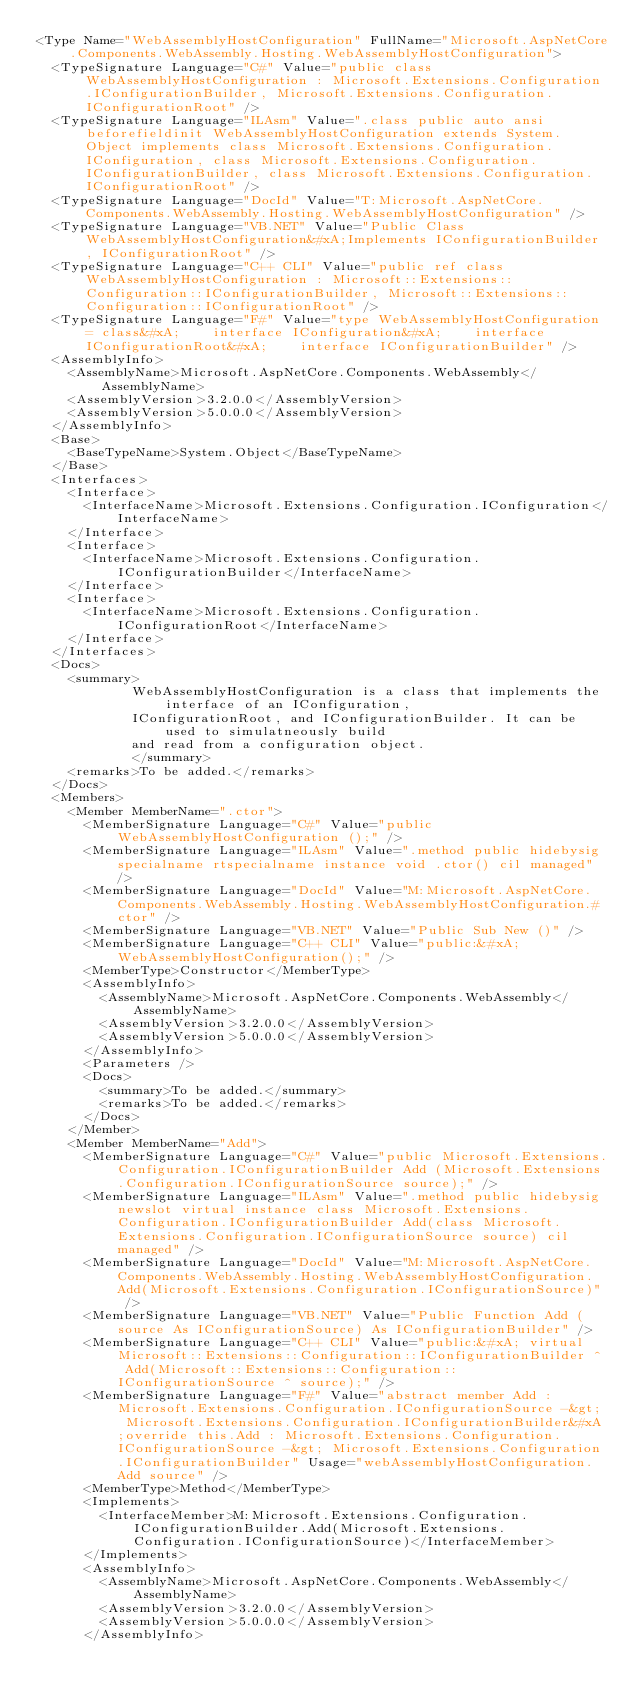Convert code to text. <code><loc_0><loc_0><loc_500><loc_500><_XML_><Type Name="WebAssemblyHostConfiguration" FullName="Microsoft.AspNetCore.Components.WebAssembly.Hosting.WebAssemblyHostConfiguration">
  <TypeSignature Language="C#" Value="public class WebAssemblyHostConfiguration : Microsoft.Extensions.Configuration.IConfigurationBuilder, Microsoft.Extensions.Configuration.IConfigurationRoot" />
  <TypeSignature Language="ILAsm" Value=".class public auto ansi beforefieldinit WebAssemblyHostConfiguration extends System.Object implements class Microsoft.Extensions.Configuration.IConfiguration, class Microsoft.Extensions.Configuration.IConfigurationBuilder, class Microsoft.Extensions.Configuration.IConfigurationRoot" />
  <TypeSignature Language="DocId" Value="T:Microsoft.AspNetCore.Components.WebAssembly.Hosting.WebAssemblyHostConfiguration" />
  <TypeSignature Language="VB.NET" Value="Public Class WebAssemblyHostConfiguration&#xA;Implements IConfigurationBuilder, IConfigurationRoot" />
  <TypeSignature Language="C++ CLI" Value="public ref class WebAssemblyHostConfiguration : Microsoft::Extensions::Configuration::IConfigurationBuilder, Microsoft::Extensions::Configuration::IConfigurationRoot" />
  <TypeSignature Language="F#" Value="type WebAssemblyHostConfiguration = class&#xA;    interface IConfiguration&#xA;    interface IConfigurationRoot&#xA;    interface IConfigurationBuilder" />
  <AssemblyInfo>
    <AssemblyName>Microsoft.AspNetCore.Components.WebAssembly</AssemblyName>
    <AssemblyVersion>3.2.0.0</AssemblyVersion>
    <AssemblyVersion>5.0.0.0</AssemblyVersion>
  </AssemblyInfo>
  <Base>
    <BaseTypeName>System.Object</BaseTypeName>
  </Base>
  <Interfaces>
    <Interface>
      <InterfaceName>Microsoft.Extensions.Configuration.IConfiguration</InterfaceName>
    </Interface>
    <Interface>
      <InterfaceName>Microsoft.Extensions.Configuration.IConfigurationBuilder</InterfaceName>
    </Interface>
    <Interface>
      <InterfaceName>Microsoft.Extensions.Configuration.IConfigurationRoot</InterfaceName>
    </Interface>
  </Interfaces>
  <Docs>
    <summary>
            WebAssemblyHostConfiguration is a class that implements the interface of an IConfiguration,
            IConfigurationRoot, and IConfigurationBuilder. It can be used to simulatneously build
            and read from a configuration object.
            </summary>
    <remarks>To be added.</remarks>
  </Docs>
  <Members>
    <Member MemberName=".ctor">
      <MemberSignature Language="C#" Value="public WebAssemblyHostConfiguration ();" />
      <MemberSignature Language="ILAsm" Value=".method public hidebysig specialname rtspecialname instance void .ctor() cil managed" />
      <MemberSignature Language="DocId" Value="M:Microsoft.AspNetCore.Components.WebAssembly.Hosting.WebAssemblyHostConfiguration.#ctor" />
      <MemberSignature Language="VB.NET" Value="Public Sub New ()" />
      <MemberSignature Language="C++ CLI" Value="public:&#xA; WebAssemblyHostConfiguration();" />
      <MemberType>Constructor</MemberType>
      <AssemblyInfo>
        <AssemblyName>Microsoft.AspNetCore.Components.WebAssembly</AssemblyName>
        <AssemblyVersion>3.2.0.0</AssemblyVersion>
        <AssemblyVersion>5.0.0.0</AssemblyVersion>
      </AssemblyInfo>
      <Parameters />
      <Docs>
        <summary>To be added.</summary>
        <remarks>To be added.</remarks>
      </Docs>
    </Member>
    <Member MemberName="Add">
      <MemberSignature Language="C#" Value="public Microsoft.Extensions.Configuration.IConfigurationBuilder Add (Microsoft.Extensions.Configuration.IConfigurationSource source);" />
      <MemberSignature Language="ILAsm" Value=".method public hidebysig newslot virtual instance class Microsoft.Extensions.Configuration.IConfigurationBuilder Add(class Microsoft.Extensions.Configuration.IConfigurationSource source) cil managed" />
      <MemberSignature Language="DocId" Value="M:Microsoft.AspNetCore.Components.WebAssembly.Hosting.WebAssemblyHostConfiguration.Add(Microsoft.Extensions.Configuration.IConfigurationSource)" />
      <MemberSignature Language="VB.NET" Value="Public Function Add (source As IConfigurationSource) As IConfigurationBuilder" />
      <MemberSignature Language="C++ CLI" Value="public:&#xA; virtual Microsoft::Extensions::Configuration::IConfigurationBuilder ^ Add(Microsoft::Extensions::Configuration::IConfigurationSource ^ source);" />
      <MemberSignature Language="F#" Value="abstract member Add : Microsoft.Extensions.Configuration.IConfigurationSource -&gt; Microsoft.Extensions.Configuration.IConfigurationBuilder&#xA;override this.Add : Microsoft.Extensions.Configuration.IConfigurationSource -&gt; Microsoft.Extensions.Configuration.IConfigurationBuilder" Usage="webAssemblyHostConfiguration.Add source" />
      <MemberType>Method</MemberType>
      <Implements>
        <InterfaceMember>M:Microsoft.Extensions.Configuration.IConfigurationBuilder.Add(Microsoft.Extensions.Configuration.IConfigurationSource)</InterfaceMember>
      </Implements>
      <AssemblyInfo>
        <AssemblyName>Microsoft.AspNetCore.Components.WebAssembly</AssemblyName>
        <AssemblyVersion>3.2.0.0</AssemblyVersion>
        <AssemblyVersion>5.0.0.0</AssemblyVersion>
      </AssemblyInfo></code> 